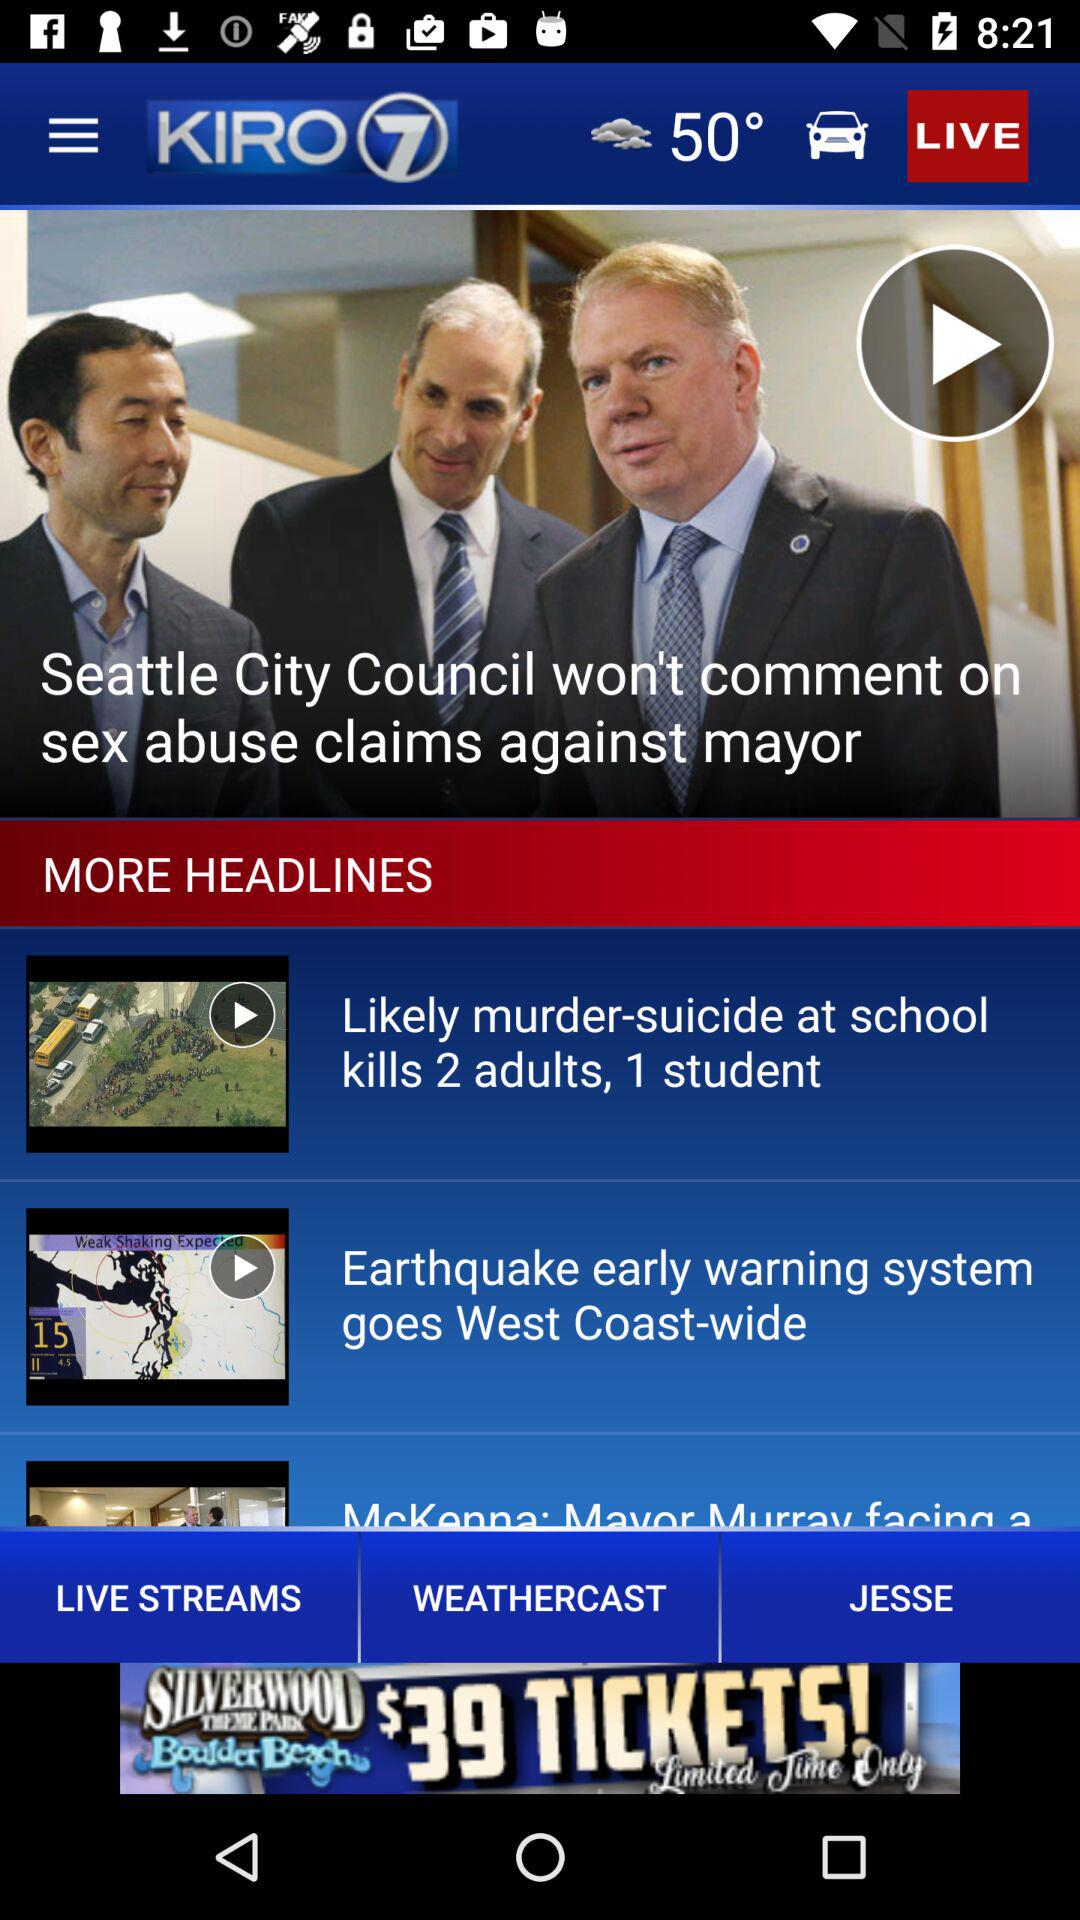What is the application name? The application name is "KIRO 7". 